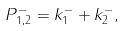Convert formula to latex. <formula><loc_0><loc_0><loc_500><loc_500>P _ { 1 , 2 } ^ { - } = k _ { 1 } ^ { - } + k _ { 2 } ^ { - } ,</formula> 